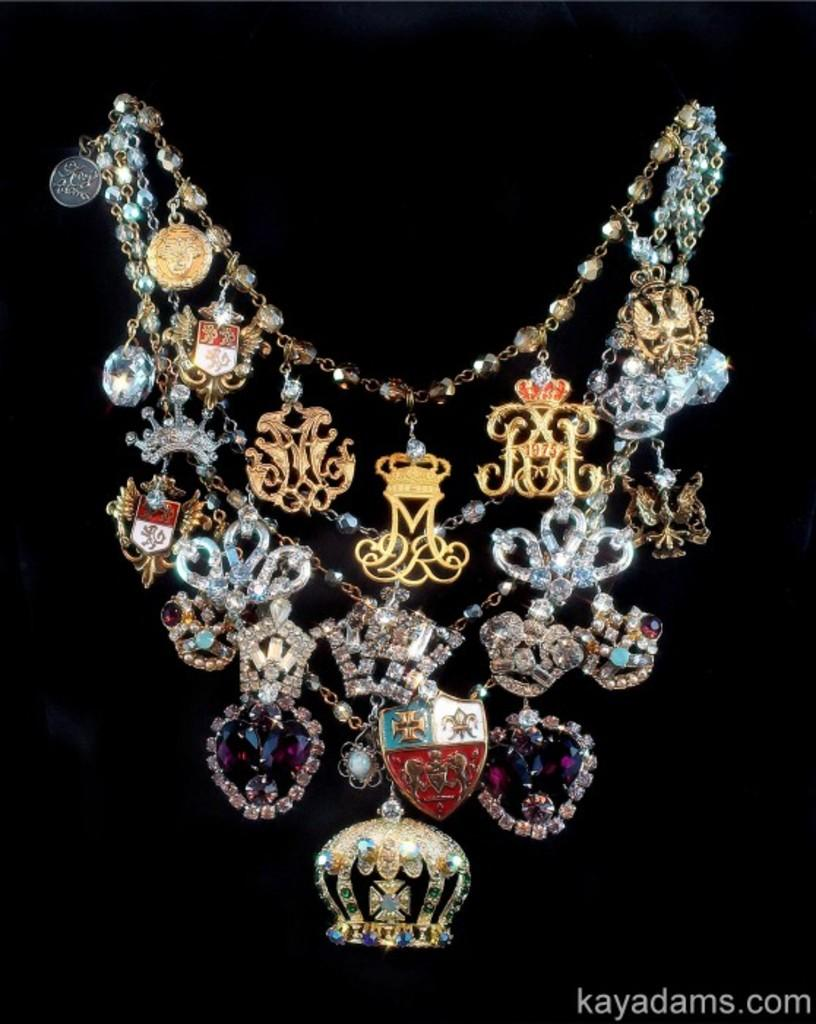What is the main object in the image? The main object in the image is a chain. What is unique about this chain? The chain has stones in it. What type of stitch is used to attach the stones to the chain in the image? There is no stitching involved in attaching the stones to the chain in the image, as they are likely held in place by the chain links themselves. 